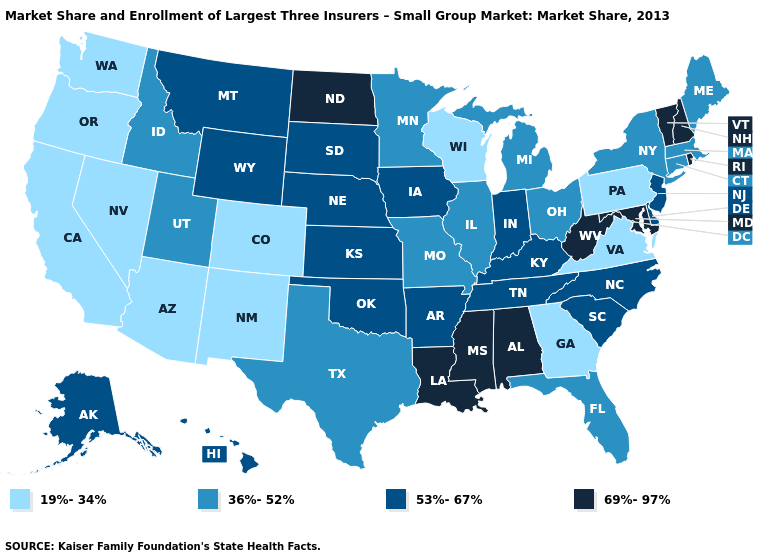Name the states that have a value in the range 53%-67%?
Be succinct. Alaska, Arkansas, Delaware, Hawaii, Indiana, Iowa, Kansas, Kentucky, Montana, Nebraska, New Jersey, North Carolina, Oklahoma, South Carolina, South Dakota, Tennessee, Wyoming. What is the highest value in the USA?
Be succinct. 69%-97%. Which states have the lowest value in the MidWest?
Be succinct. Wisconsin. What is the value of Illinois?
Answer briefly. 36%-52%. Among the states that border Georgia , which have the highest value?
Answer briefly. Alabama. What is the value of Colorado?
Short answer required. 19%-34%. Name the states that have a value in the range 19%-34%?
Keep it brief. Arizona, California, Colorado, Georgia, Nevada, New Mexico, Oregon, Pennsylvania, Virginia, Washington, Wisconsin. Name the states that have a value in the range 69%-97%?
Answer briefly. Alabama, Louisiana, Maryland, Mississippi, New Hampshire, North Dakota, Rhode Island, Vermont, West Virginia. What is the lowest value in the USA?
Concise answer only. 19%-34%. Name the states that have a value in the range 36%-52%?
Give a very brief answer. Connecticut, Florida, Idaho, Illinois, Maine, Massachusetts, Michigan, Minnesota, Missouri, New York, Ohio, Texas, Utah. What is the highest value in the USA?
Be succinct. 69%-97%. Does the map have missing data?
Concise answer only. No. What is the highest value in the MidWest ?
Concise answer only. 69%-97%. What is the lowest value in states that border New Mexico?
Quick response, please. 19%-34%. Does the map have missing data?
Quick response, please. No. 